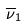Convert formula to latex. <formula><loc_0><loc_0><loc_500><loc_500>\overline { \nu } _ { 1 }</formula> 